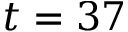Convert formula to latex. <formula><loc_0><loc_0><loc_500><loc_500>t = 3 7</formula> 